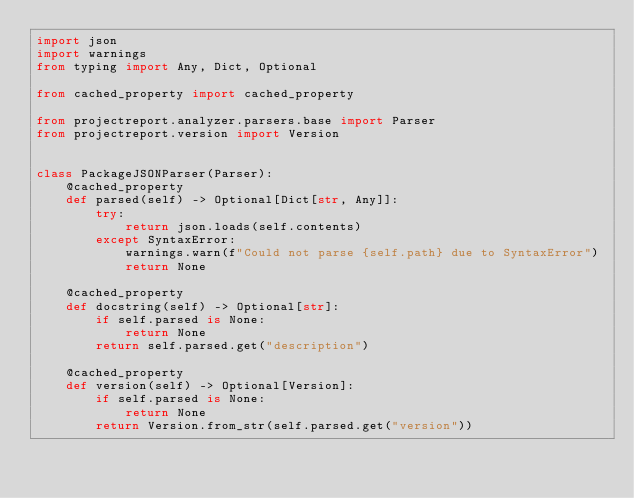Convert code to text. <code><loc_0><loc_0><loc_500><loc_500><_Python_>import json
import warnings
from typing import Any, Dict, Optional

from cached_property import cached_property

from projectreport.analyzer.parsers.base import Parser
from projectreport.version import Version


class PackageJSONParser(Parser):
    @cached_property
    def parsed(self) -> Optional[Dict[str, Any]]:
        try:
            return json.loads(self.contents)
        except SyntaxError:
            warnings.warn(f"Could not parse {self.path} due to SyntaxError")
            return None

    @cached_property
    def docstring(self) -> Optional[str]:
        if self.parsed is None:
            return None
        return self.parsed.get("description")

    @cached_property
    def version(self) -> Optional[Version]:
        if self.parsed is None:
            return None
        return Version.from_str(self.parsed.get("version"))
</code> 